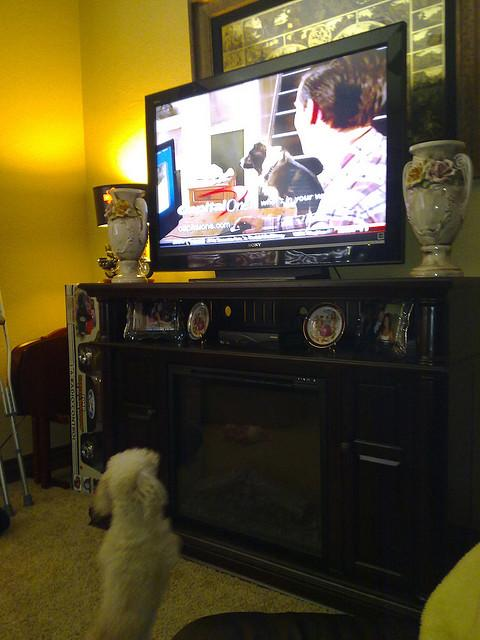What does this dog like on the TV? Please explain your reasoning. another dog. The dog is looking at the tv screen. 